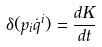<formula> <loc_0><loc_0><loc_500><loc_500>\delta ( p _ { i } \dot { q } ^ { i } ) = \frac { d K } { d t }</formula> 